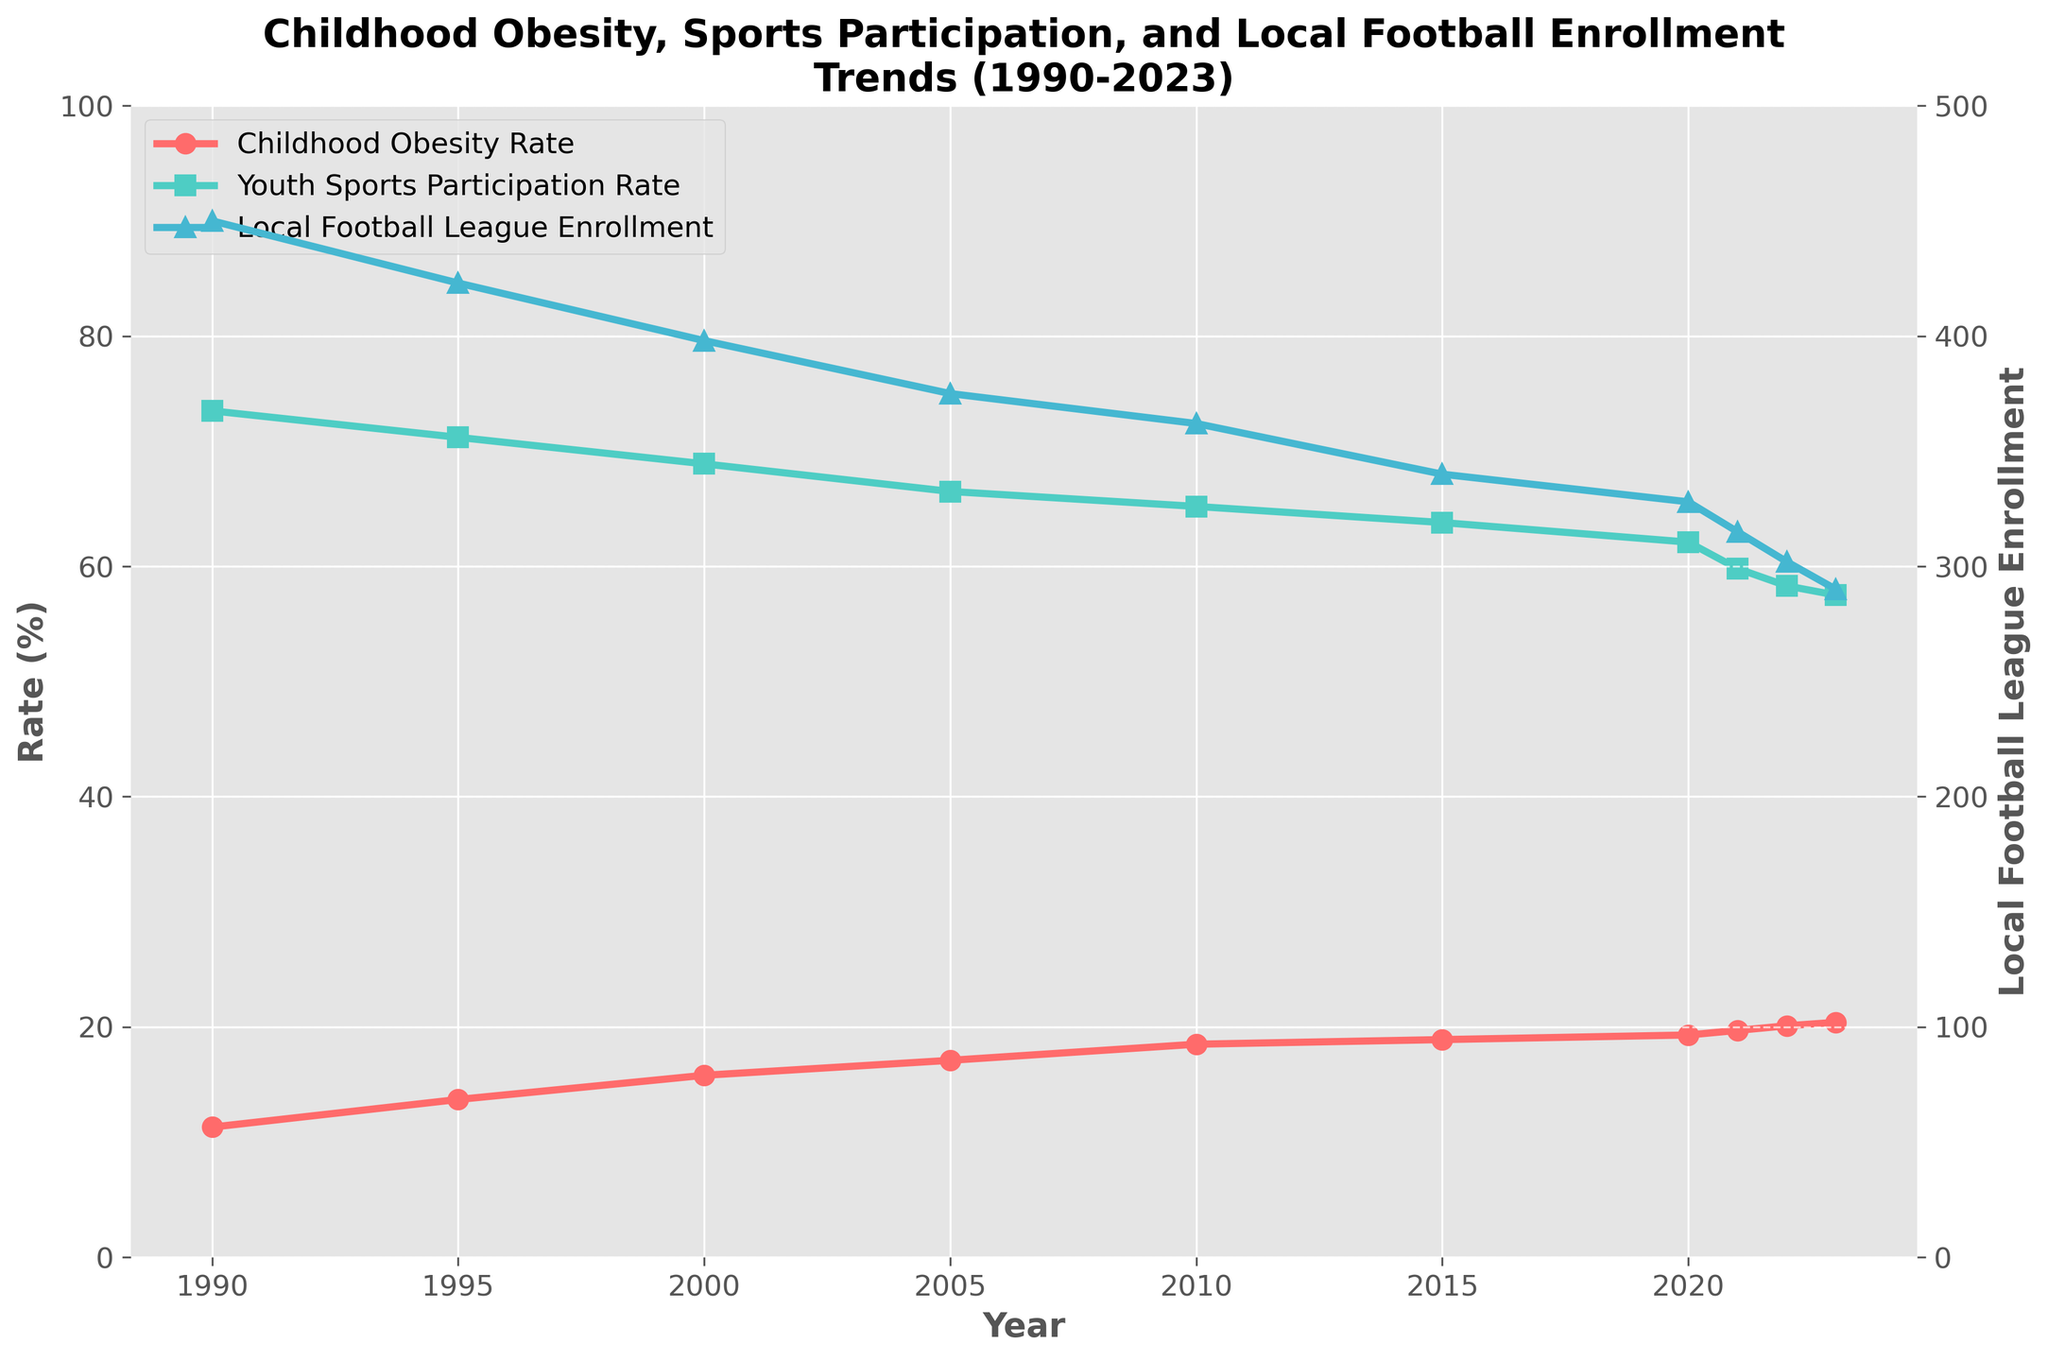What's the highest Childhood Obesity Rate recorded between 1990 and 2023? The highest Childhood Obesity Rate can be identified by looking at the peak value in the red line on the chart. The peak appears in 2023.
Answer: 20.4% What was the Childhood Obesity Rate in 2000? Locate the point on the red line corresponding to the year 2000, indicated on the x-axis.
Answer: 15.8% What’s the difference in Youth Sports Participation Rate between 1990 and 2023? Subtract the Youth Sports Participation Rate in 2023 from that in 1990. Look at the points on the green line for these years.
Answer: 16% Which year saw the Local Football League Enrollment drop below 400 for the first time? Follow the blue line and find the first year where the enrollment goes below the 400 mark.
Answer: 2000 How does the trend in Childhood Obesity Rate compare with Youth Sports Participation Rate from 1990 to 2023? Compare the rising trend in the red line (Childhood Obesity Rate) with the falling trend in the green line (Youth Sports Participation Rate).
Answer: Opposite trends, one rising, the other falling In which year is the gap between Childhood Obesity Rate and Youth Sports Participation Rate the smallest? Calculate the difference between the two rates for each year and find the year with the smallest difference.
Answer: 1990 What's the average Local Football League Enrollment from 1990 to 2023? Sum up the Local Football League Enrollment values and divide by the number of years (34+43+38+35+37+36+34+31+30+28) = 3860 and then divide by 10.
Answer: 387.5 What was the trend in Childhood Obesity Rate between 2015 and 2023? Observe the red line from 2015 to 2023 and describe how it changes.
Answer: Increasing Which year experienced the biggest drop in Youth Sports Participation Rate? Look at the green line and find the year-to-year changes. The biggest drop is between 2020 and 2021.
Answer: 2020 to 2021 In which year were the Childhood Obesity Rate and Local Football League Enrollment closest to each other? Find the year where the red and blue lines are closest together in vertical proximity on the y-axis.
Answer: They never intersect or get close due to different y-axes scales 